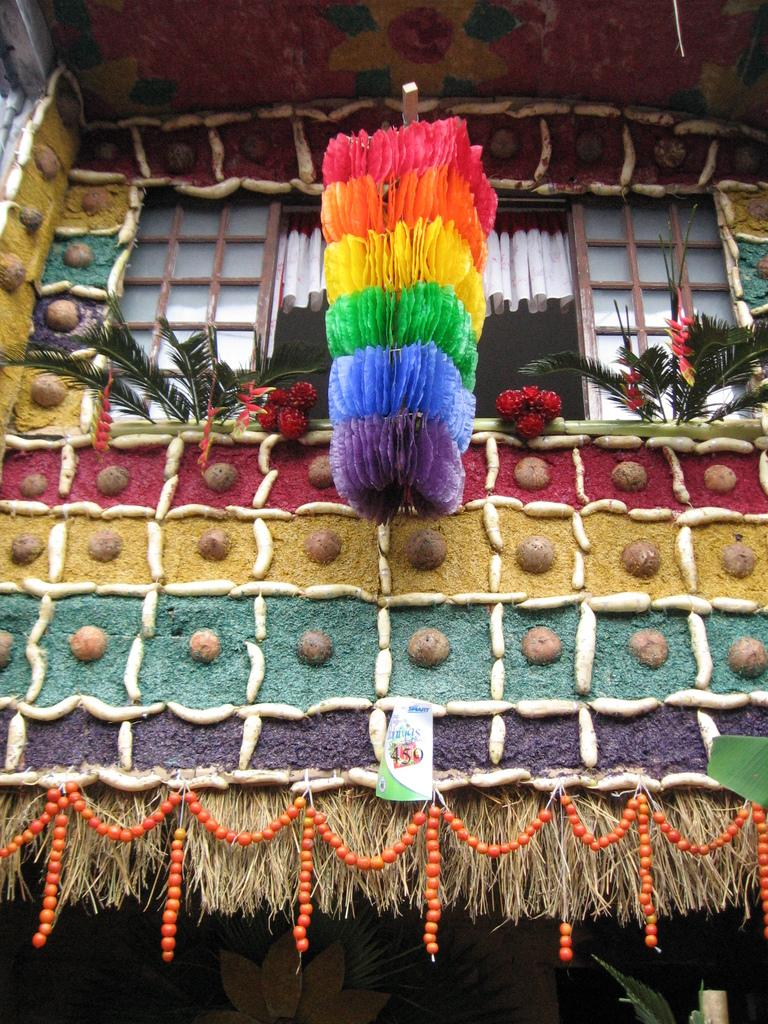What type of structure is shown in the image? The image appears to depict a house. Are there any natural elements visible in the image? Yes, there are plants visible in the image. What type of items can be seen in the image that serve a decorative purpose? There are decorative items in the image. What type of stationery items are present in the image? Color papers are present in the image. Can you see any bears playing in the sand in the image? No, there are no bears or sand present in the image. 